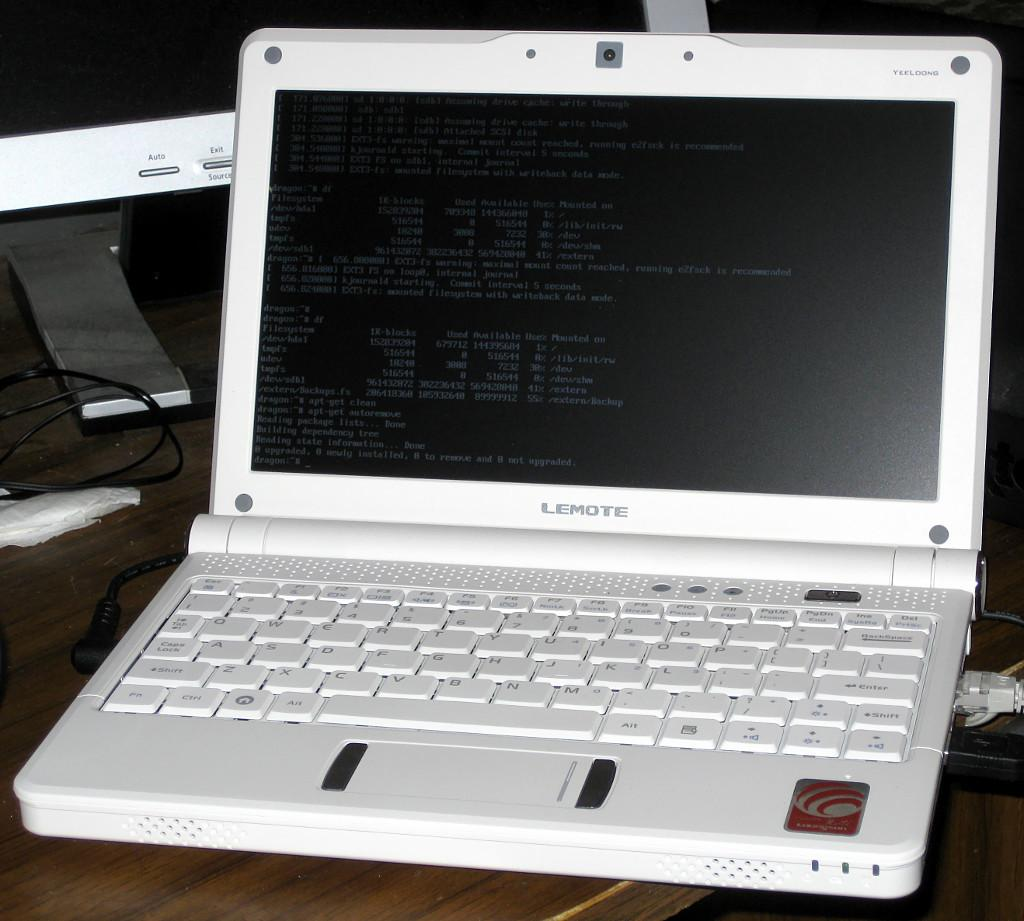What electronic device is present in the image? There is a laptop in the image. What color is the laptop? The laptop is white in color. What other electronic device can be seen in the background of the image? There is a monitor in the background of the image. What else is visible in the image besides the laptop and monitor? There are wires visible in the image. What type of zephyr can be seen blowing through the image? There is no zephyr present in the image; it is a still image with no movement or wind. How many pancakes are stacked on the laptop in the image? There are no pancakes present in the image; it features a laptop and a monitor. 